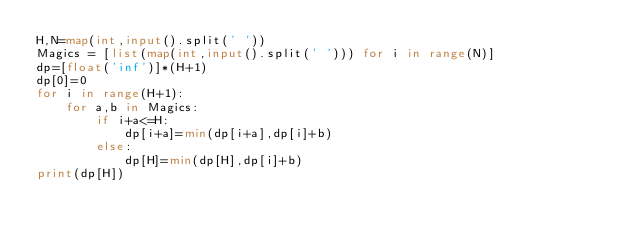<code> <loc_0><loc_0><loc_500><loc_500><_Python_>H,N=map(int,input().split(' '))
Magics = [list(map(int,input().split(' '))) for i in range(N)]
dp=[float('inf')]*(H+1)
dp[0]=0
for i in range(H+1):
    for a,b in Magics:
        if i+a<=H:
            dp[i+a]=min(dp[i+a],dp[i]+b)
        else:
            dp[H]=min(dp[H],dp[i]+b)
print(dp[H])</code> 